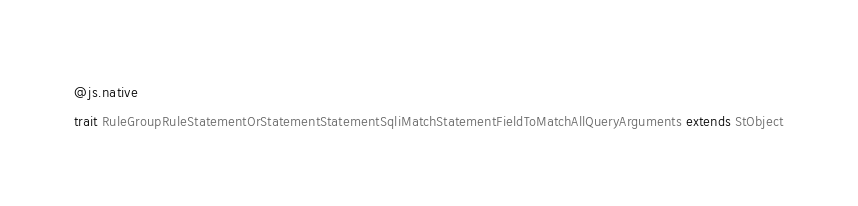<code> <loc_0><loc_0><loc_500><loc_500><_Scala_>@js.native
trait RuleGroupRuleStatementOrStatementStatementSqliMatchStatementFieldToMatchAllQueryArguments extends StObject
</code> 